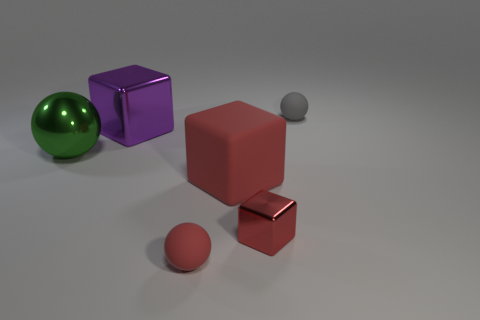Are there any large green objects in front of the tiny red metal block?
Your answer should be compact. No. There is a gray rubber object; is its shape the same as the large green metallic object in front of the purple shiny cube?
Offer a terse response. Yes. There is another tiny cube that is made of the same material as the purple cube; what color is it?
Give a very brief answer. Red. What color is the small shiny object?
Your response must be concise. Red. Does the big sphere have the same material as the large thing that is behind the big green sphere?
Provide a short and direct response. Yes. How many matte things are in front of the purple block and to the right of the tiny red sphere?
Your answer should be compact. 1. There is a matte thing that is the same size as the gray ball; what shape is it?
Your answer should be compact. Sphere. Is there a red block behind the metal object to the right of the big cube in front of the purple object?
Offer a very short reply. Yes. Does the rubber cube have the same color as the small rubber object that is in front of the tiny gray rubber sphere?
Ensure brevity in your answer.  Yes. What number of tiny spheres have the same color as the big metallic ball?
Offer a terse response. 0. 